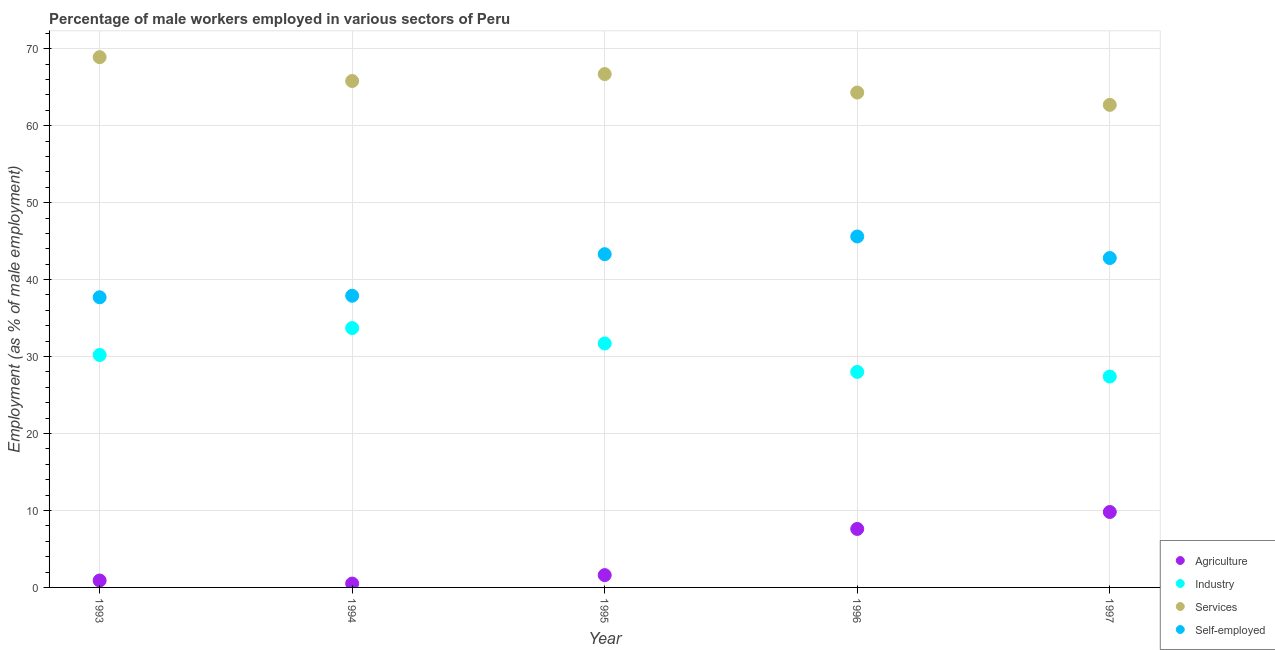How many different coloured dotlines are there?
Keep it short and to the point. 4. Is the number of dotlines equal to the number of legend labels?
Keep it short and to the point. Yes. What is the percentage of male workers in agriculture in 1995?
Offer a terse response. 1.6. Across all years, what is the maximum percentage of self employed male workers?
Your answer should be compact. 45.6. Across all years, what is the minimum percentage of male workers in services?
Keep it short and to the point. 62.7. In which year was the percentage of male workers in agriculture maximum?
Keep it short and to the point. 1997. In which year was the percentage of self employed male workers minimum?
Your answer should be compact. 1993. What is the total percentage of self employed male workers in the graph?
Ensure brevity in your answer.  207.3. What is the difference between the percentage of male workers in agriculture in 1995 and that in 1997?
Make the answer very short. -8.2. What is the difference between the percentage of male workers in services in 1997 and the percentage of male workers in agriculture in 1994?
Provide a succinct answer. 62.2. What is the average percentage of male workers in industry per year?
Make the answer very short. 30.2. In the year 1997, what is the difference between the percentage of male workers in industry and percentage of male workers in services?
Make the answer very short. -35.3. In how many years, is the percentage of male workers in agriculture greater than 52 %?
Your response must be concise. 0. What is the ratio of the percentage of male workers in services in 1994 to that in 1996?
Provide a short and direct response. 1.02. Is the difference between the percentage of male workers in industry in 1993 and 1996 greater than the difference between the percentage of male workers in agriculture in 1993 and 1996?
Offer a very short reply. Yes. What is the difference between the highest and the second highest percentage of self employed male workers?
Your answer should be very brief. 2.3. What is the difference between the highest and the lowest percentage of male workers in services?
Provide a short and direct response. 6.2. Is the sum of the percentage of male workers in agriculture in 1995 and 1996 greater than the maximum percentage of male workers in services across all years?
Offer a terse response. No. Is the percentage of male workers in agriculture strictly greater than the percentage of male workers in industry over the years?
Provide a short and direct response. No. Are the values on the major ticks of Y-axis written in scientific E-notation?
Make the answer very short. No. What is the title of the graph?
Provide a short and direct response. Percentage of male workers employed in various sectors of Peru. What is the label or title of the X-axis?
Offer a terse response. Year. What is the label or title of the Y-axis?
Give a very brief answer. Employment (as % of male employment). What is the Employment (as % of male employment) in Agriculture in 1993?
Your response must be concise. 0.9. What is the Employment (as % of male employment) in Industry in 1993?
Offer a terse response. 30.2. What is the Employment (as % of male employment) in Services in 1993?
Provide a short and direct response. 68.9. What is the Employment (as % of male employment) in Self-employed in 1993?
Offer a very short reply. 37.7. What is the Employment (as % of male employment) in Agriculture in 1994?
Give a very brief answer. 0.5. What is the Employment (as % of male employment) in Industry in 1994?
Your answer should be very brief. 33.7. What is the Employment (as % of male employment) in Services in 1994?
Make the answer very short. 65.8. What is the Employment (as % of male employment) in Self-employed in 1994?
Make the answer very short. 37.9. What is the Employment (as % of male employment) in Agriculture in 1995?
Provide a succinct answer. 1.6. What is the Employment (as % of male employment) of Industry in 1995?
Provide a succinct answer. 31.7. What is the Employment (as % of male employment) of Services in 1995?
Your answer should be very brief. 66.7. What is the Employment (as % of male employment) in Self-employed in 1995?
Your answer should be compact. 43.3. What is the Employment (as % of male employment) in Agriculture in 1996?
Offer a very short reply. 7.6. What is the Employment (as % of male employment) of Industry in 1996?
Ensure brevity in your answer.  28. What is the Employment (as % of male employment) in Services in 1996?
Provide a short and direct response. 64.3. What is the Employment (as % of male employment) of Self-employed in 1996?
Ensure brevity in your answer.  45.6. What is the Employment (as % of male employment) in Agriculture in 1997?
Ensure brevity in your answer.  9.8. What is the Employment (as % of male employment) in Industry in 1997?
Offer a terse response. 27.4. What is the Employment (as % of male employment) in Services in 1997?
Your response must be concise. 62.7. What is the Employment (as % of male employment) in Self-employed in 1997?
Make the answer very short. 42.8. Across all years, what is the maximum Employment (as % of male employment) in Agriculture?
Provide a short and direct response. 9.8. Across all years, what is the maximum Employment (as % of male employment) in Industry?
Your response must be concise. 33.7. Across all years, what is the maximum Employment (as % of male employment) of Services?
Your answer should be very brief. 68.9. Across all years, what is the maximum Employment (as % of male employment) of Self-employed?
Provide a short and direct response. 45.6. Across all years, what is the minimum Employment (as % of male employment) of Industry?
Offer a very short reply. 27.4. Across all years, what is the minimum Employment (as % of male employment) in Services?
Make the answer very short. 62.7. Across all years, what is the minimum Employment (as % of male employment) of Self-employed?
Give a very brief answer. 37.7. What is the total Employment (as % of male employment) of Agriculture in the graph?
Provide a short and direct response. 20.4. What is the total Employment (as % of male employment) of Industry in the graph?
Your answer should be very brief. 151. What is the total Employment (as % of male employment) in Services in the graph?
Your answer should be compact. 328.4. What is the total Employment (as % of male employment) of Self-employed in the graph?
Make the answer very short. 207.3. What is the difference between the Employment (as % of male employment) in Services in 1993 and that in 1994?
Ensure brevity in your answer.  3.1. What is the difference between the Employment (as % of male employment) of Self-employed in 1993 and that in 1994?
Provide a short and direct response. -0.2. What is the difference between the Employment (as % of male employment) of Agriculture in 1993 and that in 1996?
Give a very brief answer. -6.7. What is the difference between the Employment (as % of male employment) in Self-employed in 1993 and that in 1996?
Ensure brevity in your answer.  -7.9. What is the difference between the Employment (as % of male employment) of Agriculture in 1993 and that in 1997?
Give a very brief answer. -8.9. What is the difference between the Employment (as % of male employment) of Industry in 1993 and that in 1997?
Give a very brief answer. 2.8. What is the difference between the Employment (as % of male employment) of Services in 1993 and that in 1997?
Your answer should be compact. 6.2. What is the difference between the Employment (as % of male employment) in Self-employed in 1993 and that in 1997?
Provide a succinct answer. -5.1. What is the difference between the Employment (as % of male employment) in Agriculture in 1994 and that in 1995?
Ensure brevity in your answer.  -1.1. What is the difference between the Employment (as % of male employment) in Industry in 1994 and that in 1995?
Keep it short and to the point. 2. What is the difference between the Employment (as % of male employment) of Services in 1994 and that in 1995?
Keep it short and to the point. -0.9. What is the difference between the Employment (as % of male employment) of Agriculture in 1994 and that in 1996?
Make the answer very short. -7.1. What is the difference between the Employment (as % of male employment) in Self-employed in 1994 and that in 1996?
Ensure brevity in your answer.  -7.7. What is the difference between the Employment (as % of male employment) of Self-employed in 1994 and that in 1997?
Offer a very short reply. -4.9. What is the difference between the Employment (as % of male employment) of Industry in 1995 and that in 1996?
Keep it short and to the point. 3.7. What is the difference between the Employment (as % of male employment) of Services in 1995 and that in 1996?
Make the answer very short. 2.4. What is the difference between the Employment (as % of male employment) of Self-employed in 1995 and that in 1996?
Provide a succinct answer. -2.3. What is the difference between the Employment (as % of male employment) of Services in 1995 and that in 1997?
Give a very brief answer. 4. What is the difference between the Employment (as % of male employment) of Self-employed in 1995 and that in 1997?
Your answer should be compact. 0.5. What is the difference between the Employment (as % of male employment) of Services in 1996 and that in 1997?
Ensure brevity in your answer.  1.6. What is the difference between the Employment (as % of male employment) in Self-employed in 1996 and that in 1997?
Offer a very short reply. 2.8. What is the difference between the Employment (as % of male employment) of Agriculture in 1993 and the Employment (as % of male employment) of Industry in 1994?
Offer a terse response. -32.8. What is the difference between the Employment (as % of male employment) in Agriculture in 1993 and the Employment (as % of male employment) in Services in 1994?
Make the answer very short. -64.9. What is the difference between the Employment (as % of male employment) of Agriculture in 1993 and the Employment (as % of male employment) of Self-employed in 1994?
Ensure brevity in your answer.  -37. What is the difference between the Employment (as % of male employment) of Industry in 1993 and the Employment (as % of male employment) of Services in 1994?
Ensure brevity in your answer.  -35.6. What is the difference between the Employment (as % of male employment) of Industry in 1993 and the Employment (as % of male employment) of Self-employed in 1994?
Your answer should be compact. -7.7. What is the difference between the Employment (as % of male employment) in Services in 1993 and the Employment (as % of male employment) in Self-employed in 1994?
Make the answer very short. 31. What is the difference between the Employment (as % of male employment) in Agriculture in 1993 and the Employment (as % of male employment) in Industry in 1995?
Keep it short and to the point. -30.8. What is the difference between the Employment (as % of male employment) of Agriculture in 1993 and the Employment (as % of male employment) of Services in 1995?
Offer a very short reply. -65.8. What is the difference between the Employment (as % of male employment) of Agriculture in 1993 and the Employment (as % of male employment) of Self-employed in 1995?
Offer a very short reply. -42.4. What is the difference between the Employment (as % of male employment) of Industry in 1993 and the Employment (as % of male employment) of Services in 1995?
Offer a terse response. -36.5. What is the difference between the Employment (as % of male employment) in Industry in 1993 and the Employment (as % of male employment) in Self-employed in 1995?
Give a very brief answer. -13.1. What is the difference between the Employment (as % of male employment) of Services in 1993 and the Employment (as % of male employment) of Self-employed in 1995?
Your answer should be very brief. 25.6. What is the difference between the Employment (as % of male employment) in Agriculture in 1993 and the Employment (as % of male employment) in Industry in 1996?
Your answer should be compact. -27.1. What is the difference between the Employment (as % of male employment) of Agriculture in 1993 and the Employment (as % of male employment) of Services in 1996?
Your answer should be very brief. -63.4. What is the difference between the Employment (as % of male employment) in Agriculture in 1993 and the Employment (as % of male employment) in Self-employed in 1996?
Offer a very short reply. -44.7. What is the difference between the Employment (as % of male employment) in Industry in 1993 and the Employment (as % of male employment) in Services in 1996?
Provide a short and direct response. -34.1. What is the difference between the Employment (as % of male employment) in Industry in 1993 and the Employment (as % of male employment) in Self-employed in 1996?
Provide a short and direct response. -15.4. What is the difference between the Employment (as % of male employment) in Services in 1993 and the Employment (as % of male employment) in Self-employed in 1996?
Ensure brevity in your answer.  23.3. What is the difference between the Employment (as % of male employment) of Agriculture in 1993 and the Employment (as % of male employment) of Industry in 1997?
Offer a very short reply. -26.5. What is the difference between the Employment (as % of male employment) in Agriculture in 1993 and the Employment (as % of male employment) in Services in 1997?
Provide a succinct answer. -61.8. What is the difference between the Employment (as % of male employment) in Agriculture in 1993 and the Employment (as % of male employment) in Self-employed in 1997?
Your answer should be compact. -41.9. What is the difference between the Employment (as % of male employment) in Industry in 1993 and the Employment (as % of male employment) in Services in 1997?
Offer a terse response. -32.5. What is the difference between the Employment (as % of male employment) in Services in 1993 and the Employment (as % of male employment) in Self-employed in 1997?
Offer a terse response. 26.1. What is the difference between the Employment (as % of male employment) in Agriculture in 1994 and the Employment (as % of male employment) in Industry in 1995?
Offer a very short reply. -31.2. What is the difference between the Employment (as % of male employment) in Agriculture in 1994 and the Employment (as % of male employment) in Services in 1995?
Give a very brief answer. -66.2. What is the difference between the Employment (as % of male employment) in Agriculture in 1994 and the Employment (as % of male employment) in Self-employed in 1995?
Your answer should be very brief. -42.8. What is the difference between the Employment (as % of male employment) in Industry in 1994 and the Employment (as % of male employment) in Services in 1995?
Your answer should be compact. -33. What is the difference between the Employment (as % of male employment) of Agriculture in 1994 and the Employment (as % of male employment) of Industry in 1996?
Your answer should be compact. -27.5. What is the difference between the Employment (as % of male employment) in Agriculture in 1994 and the Employment (as % of male employment) in Services in 1996?
Provide a short and direct response. -63.8. What is the difference between the Employment (as % of male employment) in Agriculture in 1994 and the Employment (as % of male employment) in Self-employed in 1996?
Your answer should be compact. -45.1. What is the difference between the Employment (as % of male employment) of Industry in 1994 and the Employment (as % of male employment) of Services in 1996?
Provide a succinct answer. -30.6. What is the difference between the Employment (as % of male employment) in Industry in 1994 and the Employment (as % of male employment) in Self-employed in 1996?
Provide a short and direct response. -11.9. What is the difference between the Employment (as % of male employment) of Services in 1994 and the Employment (as % of male employment) of Self-employed in 1996?
Ensure brevity in your answer.  20.2. What is the difference between the Employment (as % of male employment) in Agriculture in 1994 and the Employment (as % of male employment) in Industry in 1997?
Your answer should be compact. -26.9. What is the difference between the Employment (as % of male employment) of Agriculture in 1994 and the Employment (as % of male employment) of Services in 1997?
Keep it short and to the point. -62.2. What is the difference between the Employment (as % of male employment) in Agriculture in 1994 and the Employment (as % of male employment) in Self-employed in 1997?
Your answer should be very brief. -42.3. What is the difference between the Employment (as % of male employment) in Agriculture in 1995 and the Employment (as % of male employment) in Industry in 1996?
Offer a terse response. -26.4. What is the difference between the Employment (as % of male employment) of Agriculture in 1995 and the Employment (as % of male employment) of Services in 1996?
Make the answer very short. -62.7. What is the difference between the Employment (as % of male employment) of Agriculture in 1995 and the Employment (as % of male employment) of Self-employed in 1996?
Give a very brief answer. -44. What is the difference between the Employment (as % of male employment) of Industry in 1995 and the Employment (as % of male employment) of Services in 1996?
Make the answer very short. -32.6. What is the difference between the Employment (as % of male employment) in Industry in 1995 and the Employment (as % of male employment) in Self-employed in 1996?
Your response must be concise. -13.9. What is the difference between the Employment (as % of male employment) of Services in 1995 and the Employment (as % of male employment) of Self-employed in 1996?
Provide a succinct answer. 21.1. What is the difference between the Employment (as % of male employment) in Agriculture in 1995 and the Employment (as % of male employment) in Industry in 1997?
Your answer should be very brief. -25.8. What is the difference between the Employment (as % of male employment) in Agriculture in 1995 and the Employment (as % of male employment) in Services in 1997?
Your answer should be compact. -61.1. What is the difference between the Employment (as % of male employment) of Agriculture in 1995 and the Employment (as % of male employment) of Self-employed in 1997?
Your response must be concise. -41.2. What is the difference between the Employment (as % of male employment) of Industry in 1995 and the Employment (as % of male employment) of Services in 1997?
Provide a short and direct response. -31. What is the difference between the Employment (as % of male employment) in Services in 1995 and the Employment (as % of male employment) in Self-employed in 1997?
Provide a short and direct response. 23.9. What is the difference between the Employment (as % of male employment) of Agriculture in 1996 and the Employment (as % of male employment) of Industry in 1997?
Provide a succinct answer. -19.8. What is the difference between the Employment (as % of male employment) of Agriculture in 1996 and the Employment (as % of male employment) of Services in 1997?
Offer a very short reply. -55.1. What is the difference between the Employment (as % of male employment) in Agriculture in 1996 and the Employment (as % of male employment) in Self-employed in 1997?
Provide a short and direct response. -35.2. What is the difference between the Employment (as % of male employment) in Industry in 1996 and the Employment (as % of male employment) in Services in 1997?
Your response must be concise. -34.7. What is the difference between the Employment (as % of male employment) of Industry in 1996 and the Employment (as % of male employment) of Self-employed in 1997?
Offer a very short reply. -14.8. What is the average Employment (as % of male employment) in Agriculture per year?
Offer a terse response. 4.08. What is the average Employment (as % of male employment) of Industry per year?
Offer a very short reply. 30.2. What is the average Employment (as % of male employment) of Services per year?
Your answer should be compact. 65.68. What is the average Employment (as % of male employment) in Self-employed per year?
Make the answer very short. 41.46. In the year 1993, what is the difference between the Employment (as % of male employment) in Agriculture and Employment (as % of male employment) in Industry?
Your answer should be compact. -29.3. In the year 1993, what is the difference between the Employment (as % of male employment) of Agriculture and Employment (as % of male employment) of Services?
Your response must be concise. -68. In the year 1993, what is the difference between the Employment (as % of male employment) in Agriculture and Employment (as % of male employment) in Self-employed?
Offer a very short reply. -36.8. In the year 1993, what is the difference between the Employment (as % of male employment) in Industry and Employment (as % of male employment) in Services?
Ensure brevity in your answer.  -38.7. In the year 1993, what is the difference between the Employment (as % of male employment) in Services and Employment (as % of male employment) in Self-employed?
Your answer should be compact. 31.2. In the year 1994, what is the difference between the Employment (as % of male employment) of Agriculture and Employment (as % of male employment) of Industry?
Make the answer very short. -33.2. In the year 1994, what is the difference between the Employment (as % of male employment) in Agriculture and Employment (as % of male employment) in Services?
Your answer should be very brief. -65.3. In the year 1994, what is the difference between the Employment (as % of male employment) in Agriculture and Employment (as % of male employment) in Self-employed?
Keep it short and to the point. -37.4. In the year 1994, what is the difference between the Employment (as % of male employment) in Industry and Employment (as % of male employment) in Services?
Your response must be concise. -32.1. In the year 1994, what is the difference between the Employment (as % of male employment) of Industry and Employment (as % of male employment) of Self-employed?
Keep it short and to the point. -4.2. In the year 1994, what is the difference between the Employment (as % of male employment) of Services and Employment (as % of male employment) of Self-employed?
Your answer should be very brief. 27.9. In the year 1995, what is the difference between the Employment (as % of male employment) in Agriculture and Employment (as % of male employment) in Industry?
Provide a short and direct response. -30.1. In the year 1995, what is the difference between the Employment (as % of male employment) of Agriculture and Employment (as % of male employment) of Services?
Make the answer very short. -65.1. In the year 1995, what is the difference between the Employment (as % of male employment) in Agriculture and Employment (as % of male employment) in Self-employed?
Your response must be concise. -41.7. In the year 1995, what is the difference between the Employment (as % of male employment) in Industry and Employment (as % of male employment) in Services?
Offer a terse response. -35. In the year 1995, what is the difference between the Employment (as % of male employment) in Services and Employment (as % of male employment) in Self-employed?
Your response must be concise. 23.4. In the year 1996, what is the difference between the Employment (as % of male employment) in Agriculture and Employment (as % of male employment) in Industry?
Your answer should be very brief. -20.4. In the year 1996, what is the difference between the Employment (as % of male employment) in Agriculture and Employment (as % of male employment) in Services?
Make the answer very short. -56.7. In the year 1996, what is the difference between the Employment (as % of male employment) in Agriculture and Employment (as % of male employment) in Self-employed?
Your answer should be compact. -38. In the year 1996, what is the difference between the Employment (as % of male employment) of Industry and Employment (as % of male employment) of Services?
Offer a very short reply. -36.3. In the year 1996, what is the difference between the Employment (as % of male employment) in Industry and Employment (as % of male employment) in Self-employed?
Give a very brief answer. -17.6. In the year 1996, what is the difference between the Employment (as % of male employment) in Services and Employment (as % of male employment) in Self-employed?
Offer a terse response. 18.7. In the year 1997, what is the difference between the Employment (as % of male employment) of Agriculture and Employment (as % of male employment) of Industry?
Provide a succinct answer. -17.6. In the year 1997, what is the difference between the Employment (as % of male employment) in Agriculture and Employment (as % of male employment) in Services?
Your answer should be compact. -52.9. In the year 1997, what is the difference between the Employment (as % of male employment) of Agriculture and Employment (as % of male employment) of Self-employed?
Give a very brief answer. -33. In the year 1997, what is the difference between the Employment (as % of male employment) of Industry and Employment (as % of male employment) of Services?
Keep it short and to the point. -35.3. In the year 1997, what is the difference between the Employment (as % of male employment) of Industry and Employment (as % of male employment) of Self-employed?
Your response must be concise. -15.4. What is the ratio of the Employment (as % of male employment) of Agriculture in 1993 to that in 1994?
Offer a very short reply. 1.8. What is the ratio of the Employment (as % of male employment) of Industry in 1993 to that in 1994?
Keep it short and to the point. 0.9. What is the ratio of the Employment (as % of male employment) of Services in 1993 to that in 1994?
Your answer should be compact. 1.05. What is the ratio of the Employment (as % of male employment) of Self-employed in 1993 to that in 1994?
Your answer should be compact. 0.99. What is the ratio of the Employment (as % of male employment) of Agriculture in 1993 to that in 1995?
Make the answer very short. 0.56. What is the ratio of the Employment (as % of male employment) in Industry in 1993 to that in 1995?
Ensure brevity in your answer.  0.95. What is the ratio of the Employment (as % of male employment) in Services in 1993 to that in 1995?
Give a very brief answer. 1.03. What is the ratio of the Employment (as % of male employment) in Self-employed in 1993 to that in 1995?
Ensure brevity in your answer.  0.87. What is the ratio of the Employment (as % of male employment) in Agriculture in 1993 to that in 1996?
Keep it short and to the point. 0.12. What is the ratio of the Employment (as % of male employment) of Industry in 1993 to that in 1996?
Make the answer very short. 1.08. What is the ratio of the Employment (as % of male employment) of Services in 1993 to that in 1996?
Keep it short and to the point. 1.07. What is the ratio of the Employment (as % of male employment) of Self-employed in 1993 to that in 1996?
Keep it short and to the point. 0.83. What is the ratio of the Employment (as % of male employment) in Agriculture in 1993 to that in 1997?
Give a very brief answer. 0.09. What is the ratio of the Employment (as % of male employment) of Industry in 1993 to that in 1997?
Offer a very short reply. 1.1. What is the ratio of the Employment (as % of male employment) in Services in 1993 to that in 1997?
Your response must be concise. 1.1. What is the ratio of the Employment (as % of male employment) of Self-employed in 1993 to that in 1997?
Your response must be concise. 0.88. What is the ratio of the Employment (as % of male employment) of Agriculture in 1994 to that in 1995?
Your answer should be compact. 0.31. What is the ratio of the Employment (as % of male employment) of Industry in 1994 to that in 1995?
Make the answer very short. 1.06. What is the ratio of the Employment (as % of male employment) in Services in 1994 to that in 1995?
Provide a succinct answer. 0.99. What is the ratio of the Employment (as % of male employment) of Self-employed in 1994 to that in 1995?
Your response must be concise. 0.88. What is the ratio of the Employment (as % of male employment) in Agriculture in 1994 to that in 1996?
Make the answer very short. 0.07. What is the ratio of the Employment (as % of male employment) in Industry in 1994 to that in 1996?
Your response must be concise. 1.2. What is the ratio of the Employment (as % of male employment) of Services in 1994 to that in 1996?
Offer a very short reply. 1.02. What is the ratio of the Employment (as % of male employment) of Self-employed in 1994 to that in 1996?
Your answer should be compact. 0.83. What is the ratio of the Employment (as % of male employment) of Agriculture in 1994 to that in 1997?
Provide a short and direct response. 0.05. What is the ratio of the Employment (as % of male employment) in Industry in 1994 to that in 1997?
Make the answer very short. 1.23. What is the ratio of the Employment (as % of male employment) of Services in 1994 to that in 1997?
Give a very brief answer. 1.05. What is the ratio of the Employment (as % of male employment) in Self-employed in 1994 to that in 1997?
Provide a short and direct response. 0.89. What is the ratio of the Employment (as % of male employment) in Agriculture in 1995 to that in 1996?
Provide a short and direct response. 0.21. What is the ratio of the Employment (as % of male employment) of Industry in 1995 to that in 1996?
Your answer should be compact. 1.13. What is the ratio of the Employment (as % of male employment) in Services in 1995 to that in 1996?
Your answer should be compact. 1.04. What is the ratio of the Employment (as % of male employment) in Self-employed in 1995 to that in 1996?
Offer a terse response. 0.95. What is the ratio of the Employment (as % of male employment) of Agriculture in 1995 to that in 1997?
Make the answer very short. 0.16. What is the ratio of the Employment (as % of male employment) of Industry in 1995 to that in 1997?
Make the answer very short. 1.16. What is the ratio of the Employment (as % of male employment) in Services in 1995 to that in 1997?
Ensure brevity in your answer.  1.06. What is the ratio of the Employment (as % of male employment) of Self-employed in 1995 to that in 1997?
Your answer should be compact. 1.01. What is the ratio of the Employment (as % of male employment) of Agriculture in 1996 to that in 1997?
Provide a short and direct response. 0.78. What is the ratio of the Employment (as % of male employment) of Industry in 1996 to that in 1997?
Provide a short and direct response. 1.02. What is the ratio of the Employment (as % of male employment) of Services in 1996 to that in 1997?
Ensure brevity in your answer.  1.03. What is the ratio of the Employment (as % of male employment) of Self-employed in 1996 to that in 1997?
Make the answer very short. 1.07. What is the difference between the highest and the second highest Employment (as % of male employment) of Agriculture?
Your answer should be very brief. 2.2. What is the difference between the highest and the second highest Employment (as % of male employment) in Services?
Ensure brevity in your answer.  2.2. What is the difference between the highest and the second highest Employment (as % of male employment) of Self-employed?
Provide a succinct answer. 2.3. What is the difference between the highest and the lowest Employment (as % of male employment) of Industry?
Your response must be concise. 6.3. What is the difference between the highest and the lowest Employment (as % of male employment) in Services?
Give a very brief answer. 6.2. 